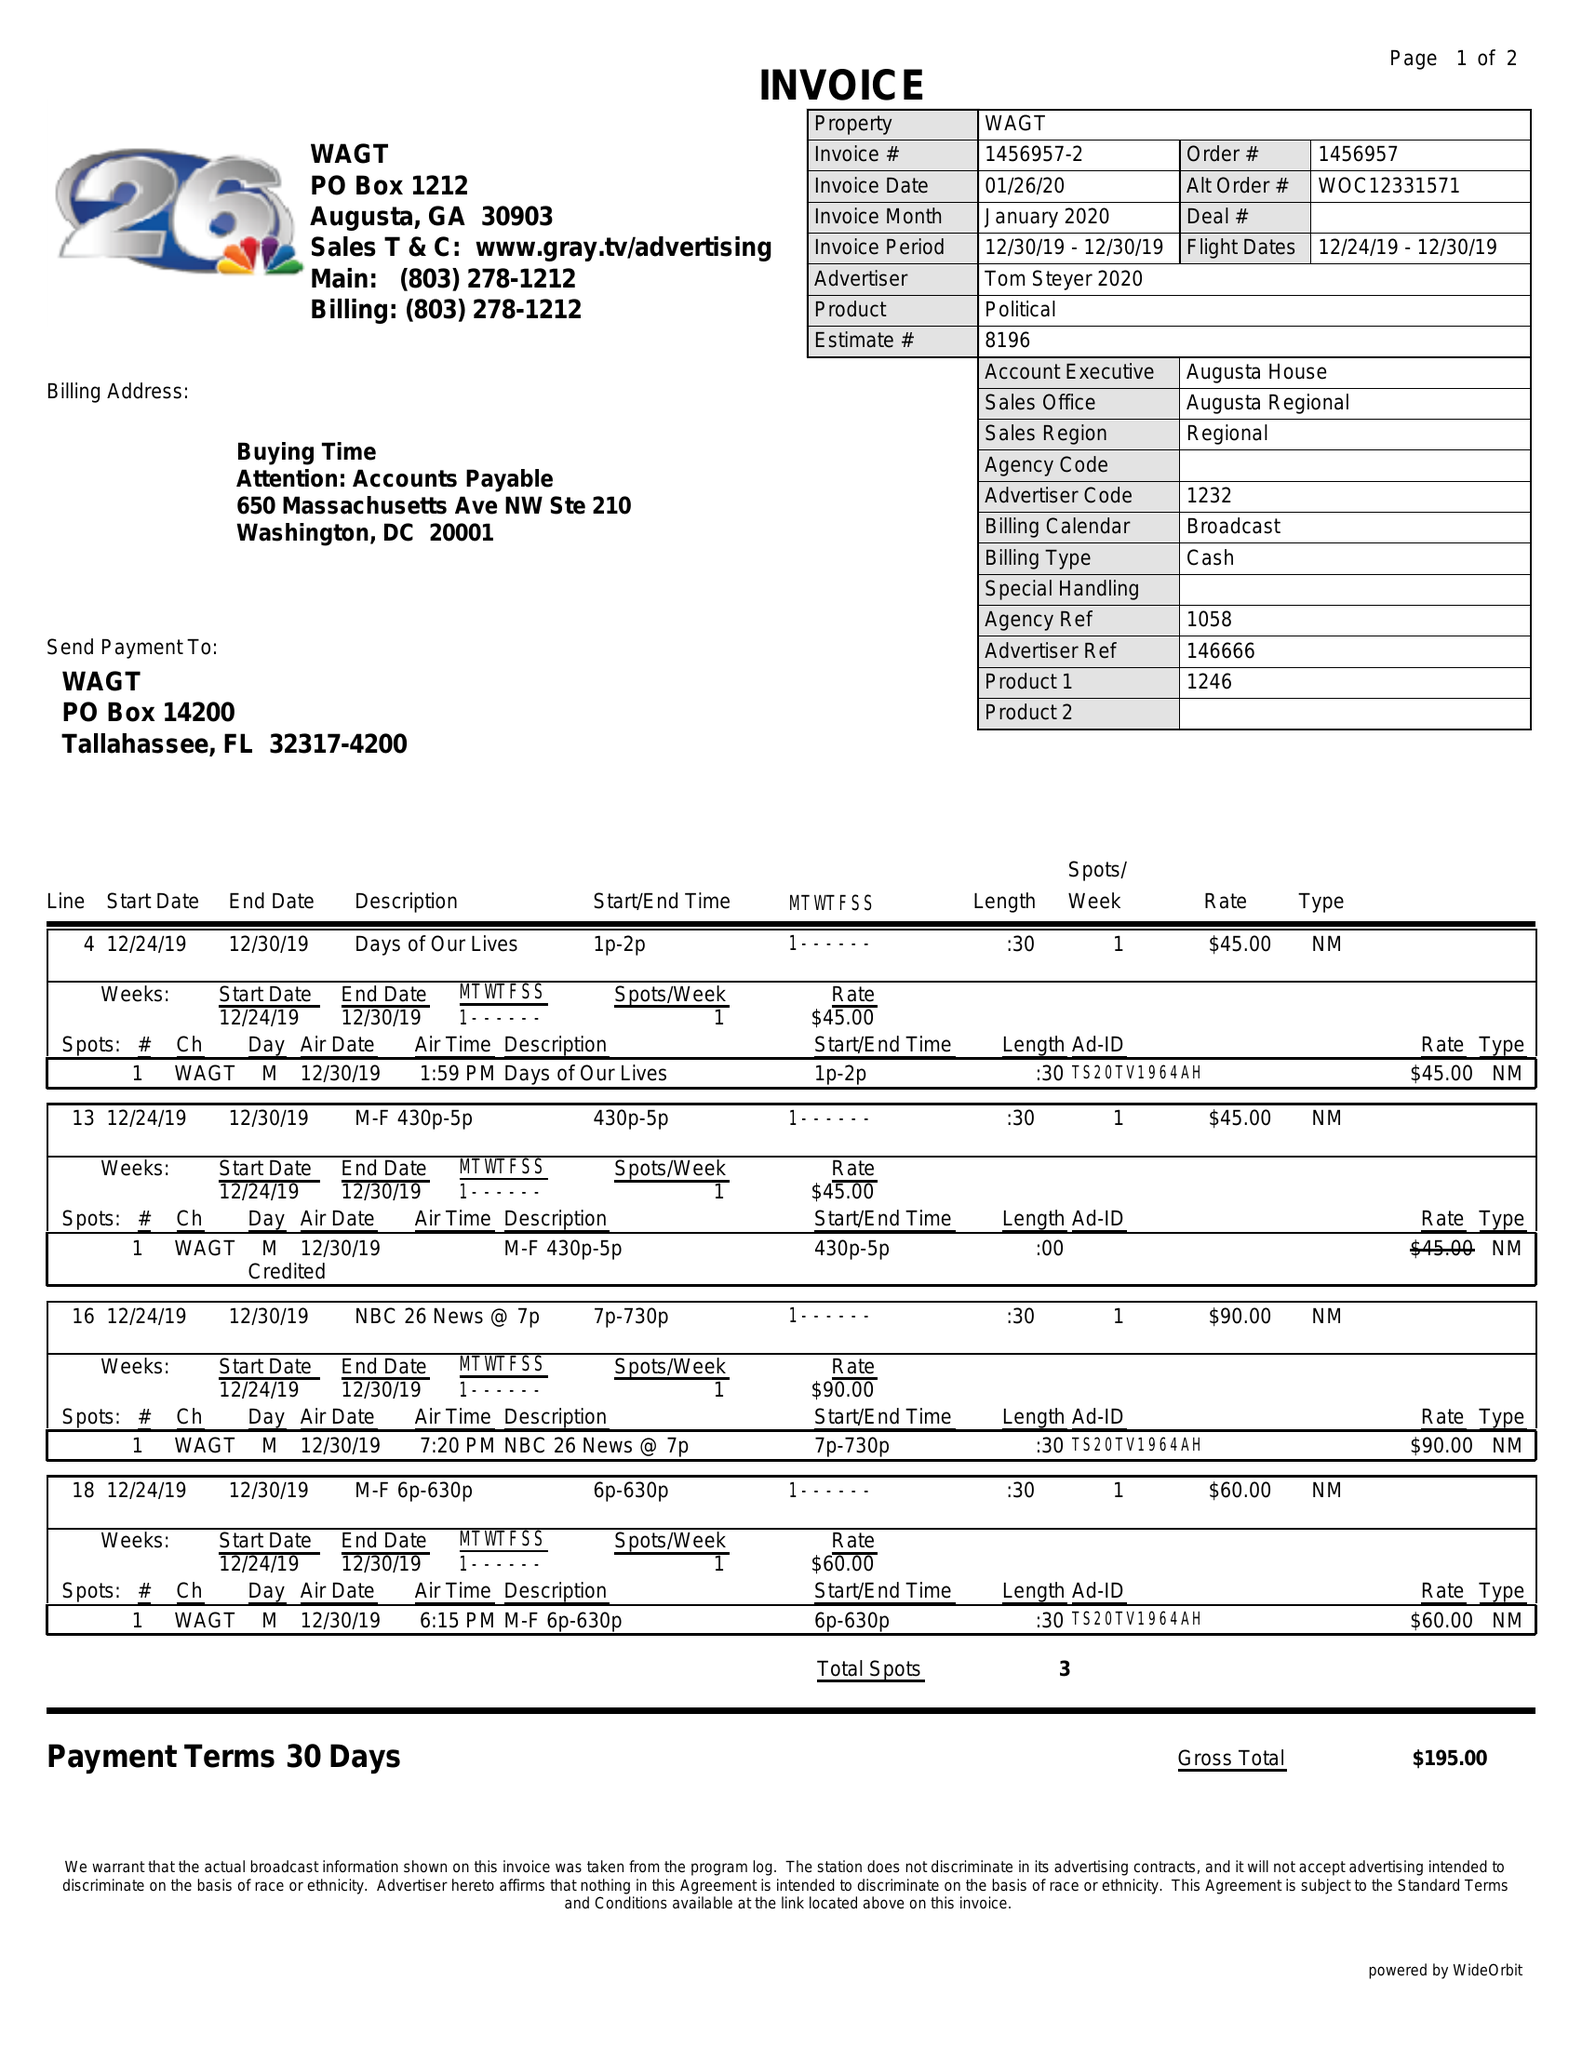What is the value for the contract_num?
Answer the question using a single word or phrase. 1456957 